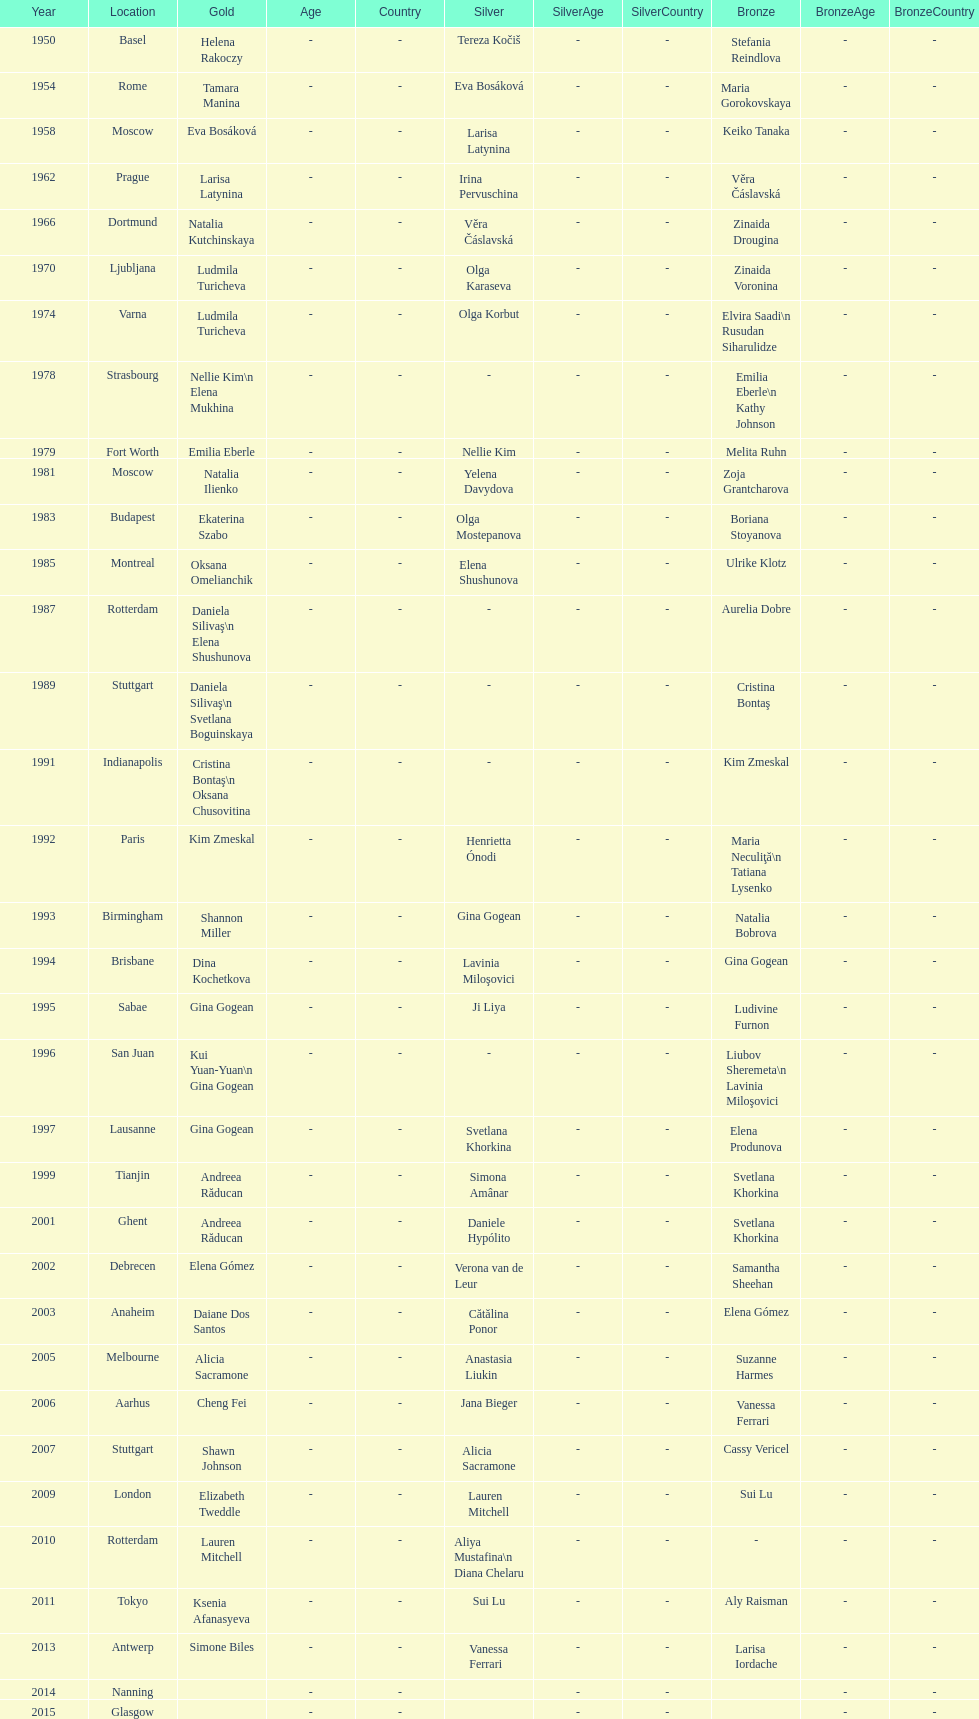How long is the time between the times the championship was held in moscow? 23 years. 